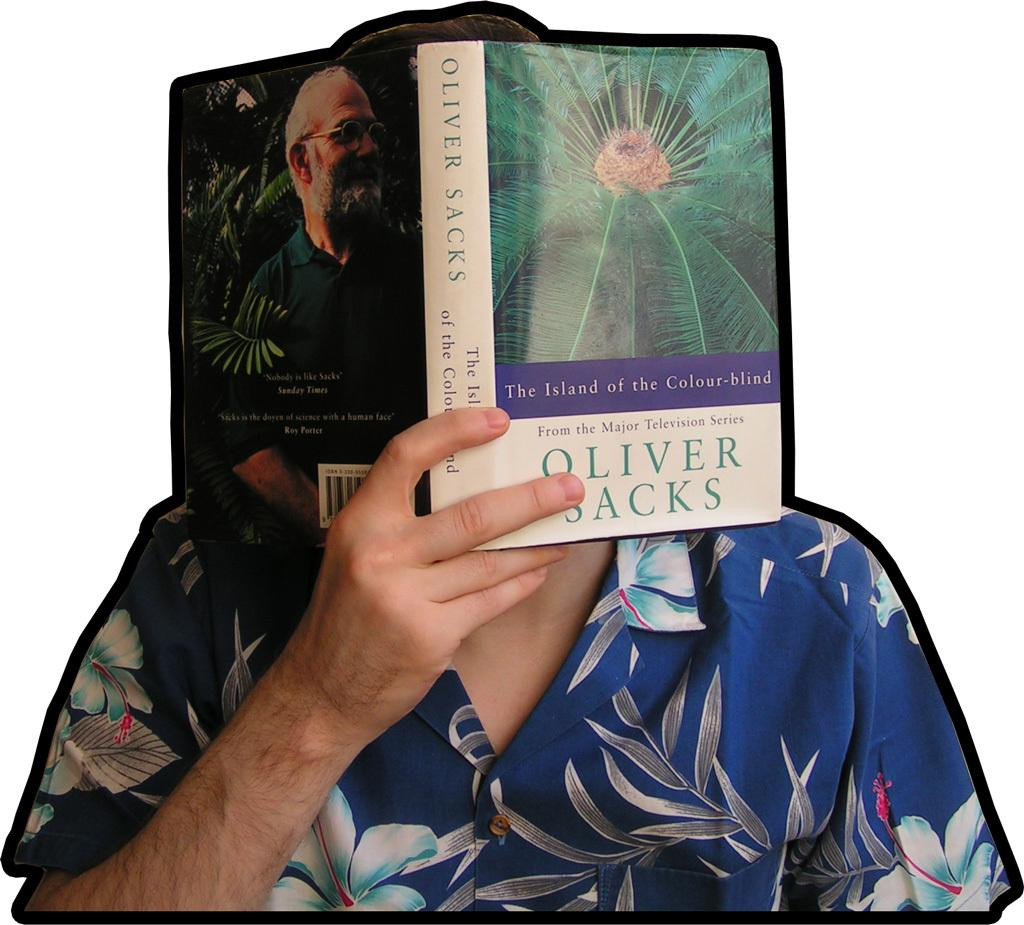What is the main subject in the foreground of the image? There is a person in the foreground of the image. What is the person holding in the image? The person is holding a book. What is the person doing with their face in the image? The person is covering their face. What color is the background of the image? The background of the image is white. What type of jelly can be seen on the person's face in the image? There is no jelly present on the person's face in the image. Is there a ghost visible in the image? There is no ghost present in the image. 